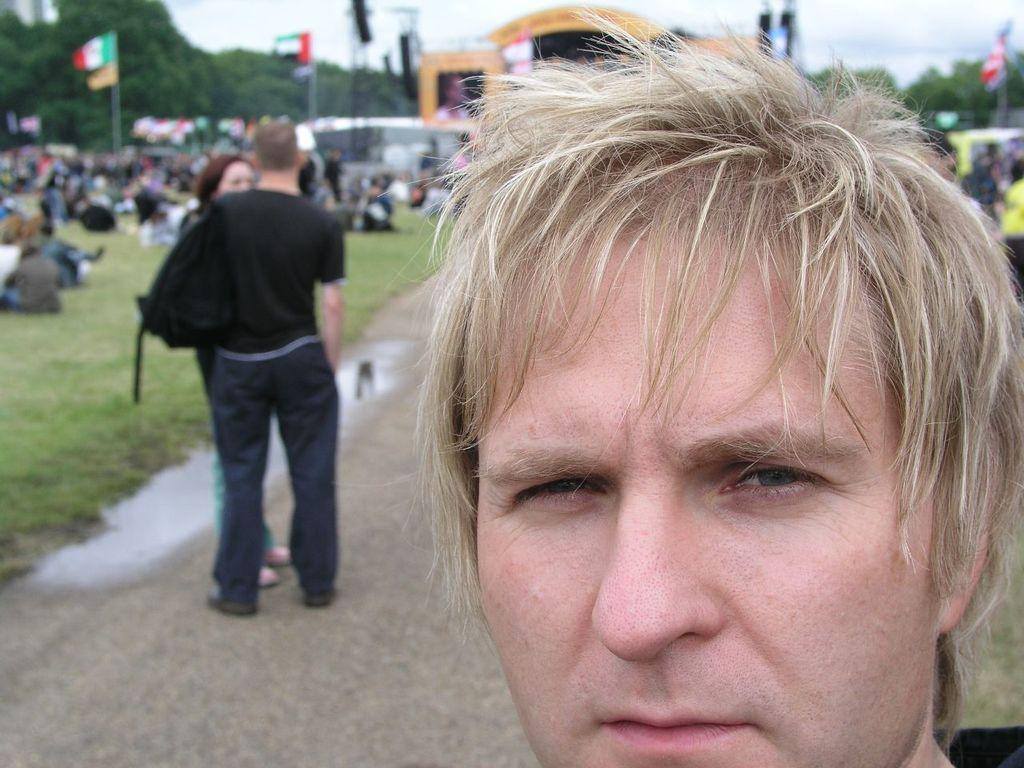What is the main subject in the foreground of the image? There is a person in the foreground of the image. What can be seen in the background of the image? There are people, flags, grassland, trees, and the sky visible in the background of the image. How many divisions can be seen in the thumb of the person in the image? There is no thumb visible in the image, and therefore no divisions can be counted. 